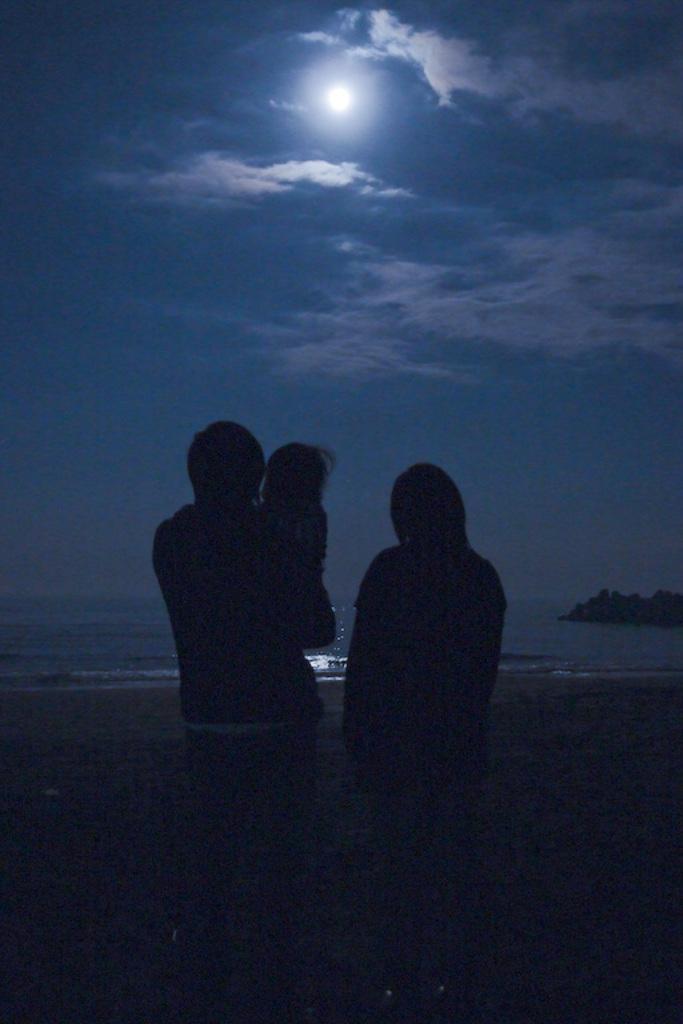How would you summarize this image in a sentence or two? In the picture I can see a woman and a man. I can see a man holding a baby. In the background, I can see the ocean. I can see a moon and clouds in the sky. 